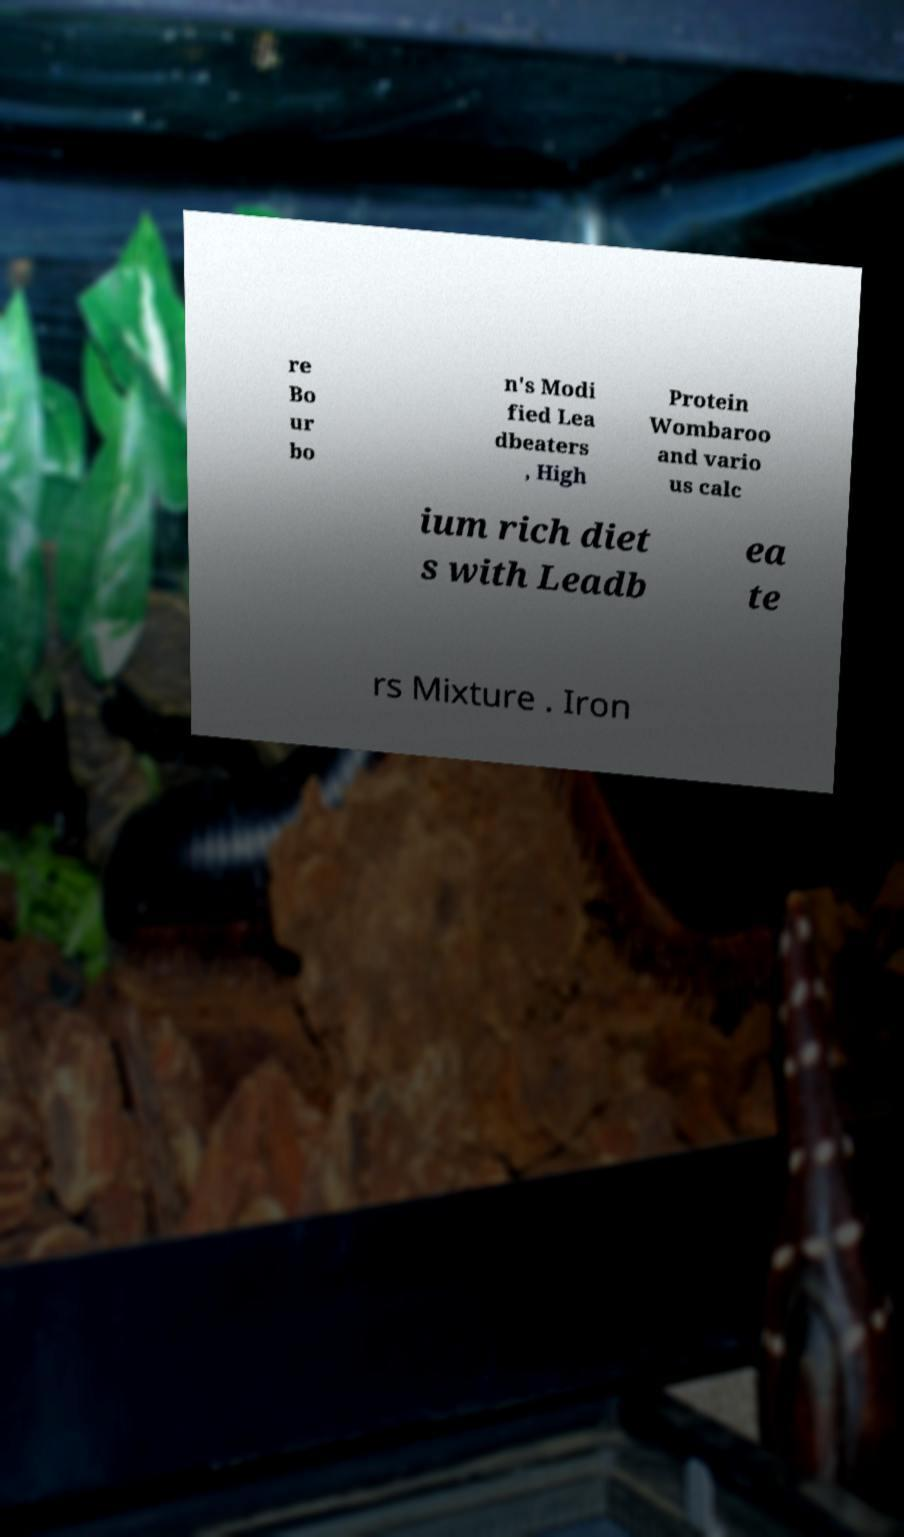Can you read and provide the text displayed in the image?This photo seems to have some interesting text. Can you extract and type it out for me? re Bo ur bo n's Modi fied Lea dbeaters , High Protein Wombaroo and vario us calc ium rich diet s with Leadb ea te rs Mixture . Iron 